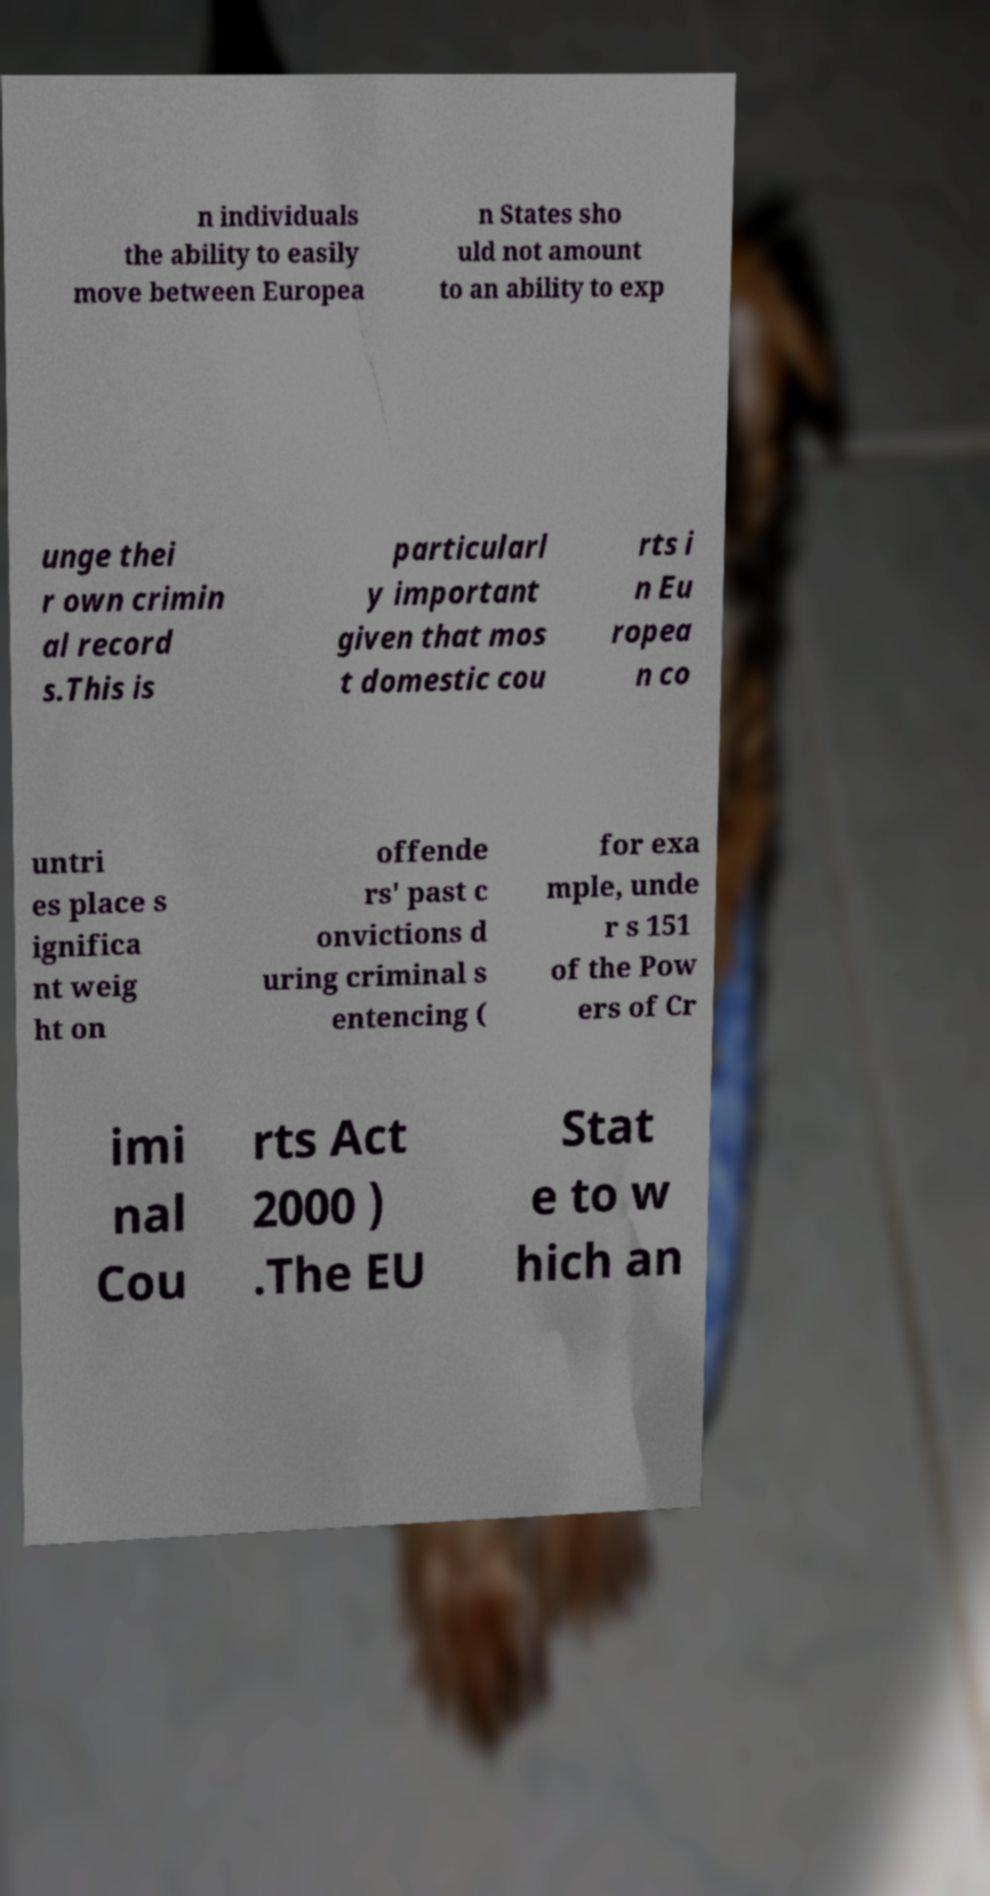There's text embedded in this image that I need extracted. Can you transcribe it verbatim? n individuals the ability to easily move between Europea n States sho uld not amount to an ability to exp unge thei r own crimin al record s.This is particularl y important given that mos t domestic cou rts i n Eu ropea n co untri es place s ignifica nt weig ht on offende rs' past c onvictions d uring criminal s entencing ( for exa mple, unde r s 151 of the Pow ers of Cr imi nal Cou rts Act 2000 ) .The EU Stat e to w hich an 